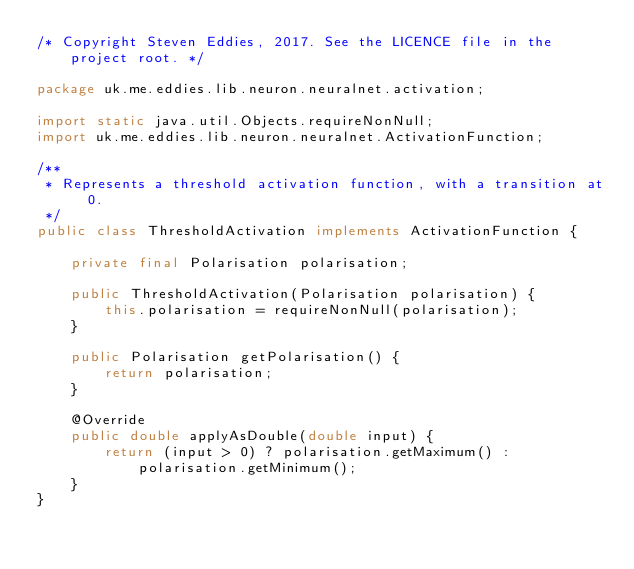<code> <loc_0><loc_0><loc_500><loc_500><_Java_>/* Copyright Steven Eddies, 2017. See the LICENCE file in the project root. */

package uk.me.eddies.lib.neuron.neuralnet.activation;

import static java.util.Objects.requireNonNull;
import uk.me.eddies.lib.neuron.neuralnet.ActivationFunction;

/**
 * Represents a threshold activation function, with a transition at 0.
 */
public class ThresholdActivation implements ActivationFunction {

	private final Polarisation polarisation;

	public ThresholdActivation(Polarisation polarisation) {
		this.polarisation = requireNonNull(polarisation);
	}

	public Polarisation getPolarisation() {
		return polarisation;
	}

	@Override
	public double applyAsDouble(double input) {
		return (input > 0) ? polarisation.getMaximum() : polarisation.getMinimum();
	}
}
</code> 